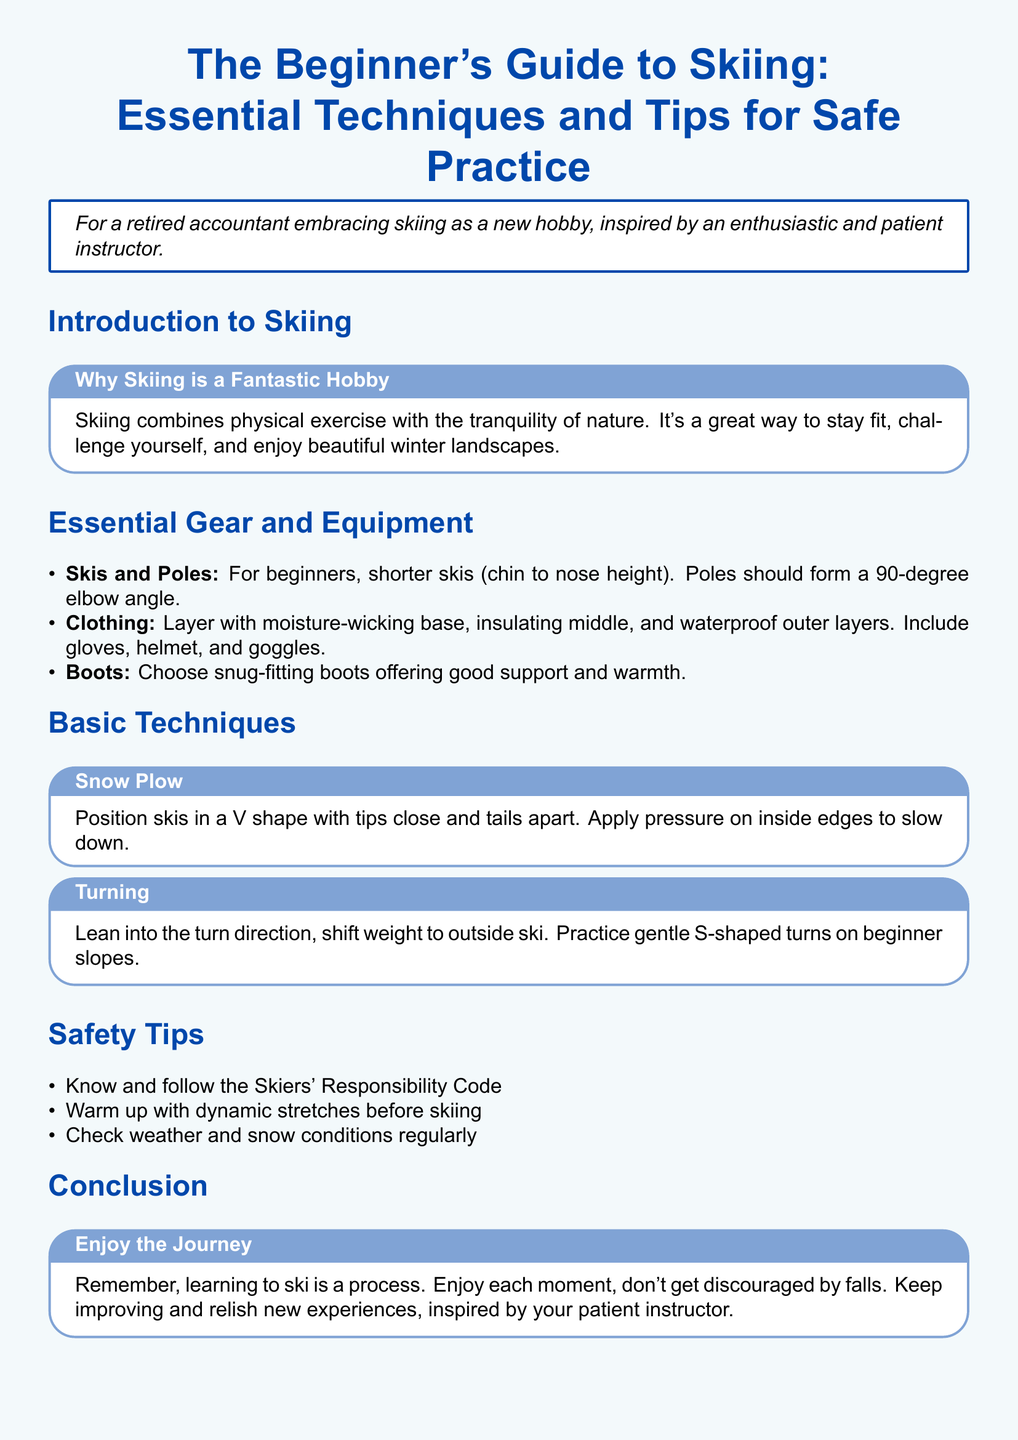What is the title of the guide? The title is stated prominently at the top of the document, showcasing the focus on beginner skiing techniques and safety tips.
Answer: The Beginner's Guide to Skiing: Essential Techniques and Tips for Safe Practice Why is skiing described as a fantastic hobby? The document highlights the benefits of skiing, combining physical exercise with enjoying nature, which makes it appealing.
Answer: It combines physical exercise with the tranquility of nature What height should beginner skis be? The document recommends a specific height range for beginner skis, aiding in selection for new skiers.
Answer: Chin to nose height What shape do you position skis in for the snow plow technique? The snow plow technique requires a specific arrangement of the skis for effective speed control.
Answer: V shape What is recommended before skiing? The document advises on a preparation activity that helps prevent injury and prepares the skier physically.
Answer: Dynamic stretches What type of clothing is suggested for skiing? Clothing recommendations are provided to ensure skiers remain warm and dry while engaging in the sport.
Answer: Layer with moisture-wicking base, insulating middle, and waterproof outer layers What should skiers check regularly? A critical aspect of skiing safety involves monitoring certain environmental factors before heading out on the slopes.
Answer: Weather and snow conditions What attitude should skiers have while learning? The concluding advice reflects the overall attitude towards the learning process in skiing, emphasizing enjoyment over frustration.
Answer: Enjoy each moment 